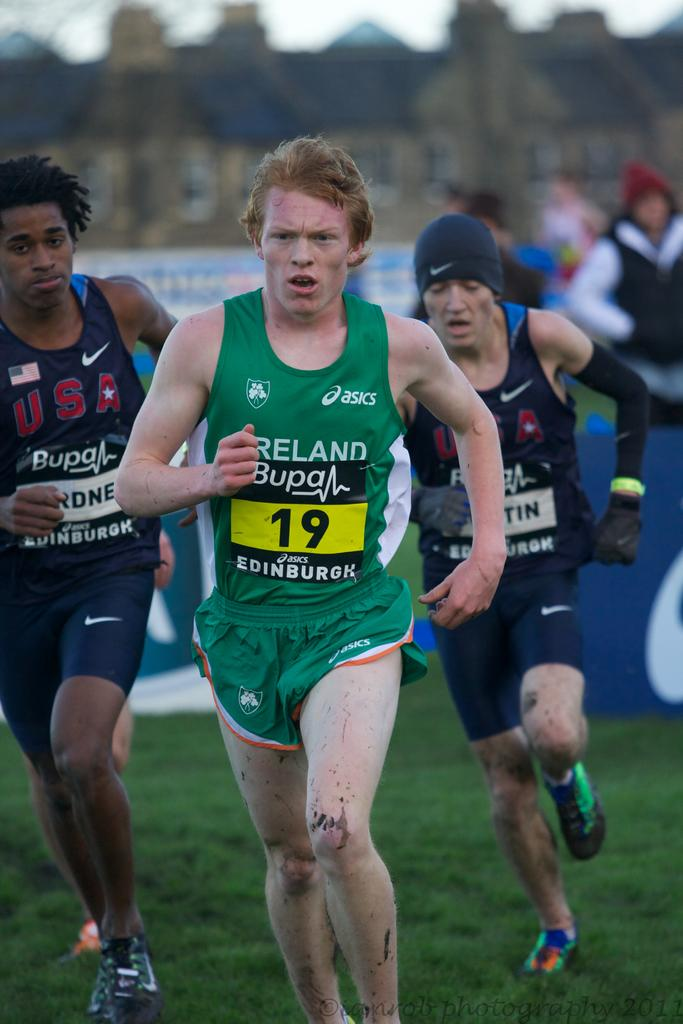<image>
Present a compact description of the photo's key features. Some runners, the one on the left has USA on his vest. 